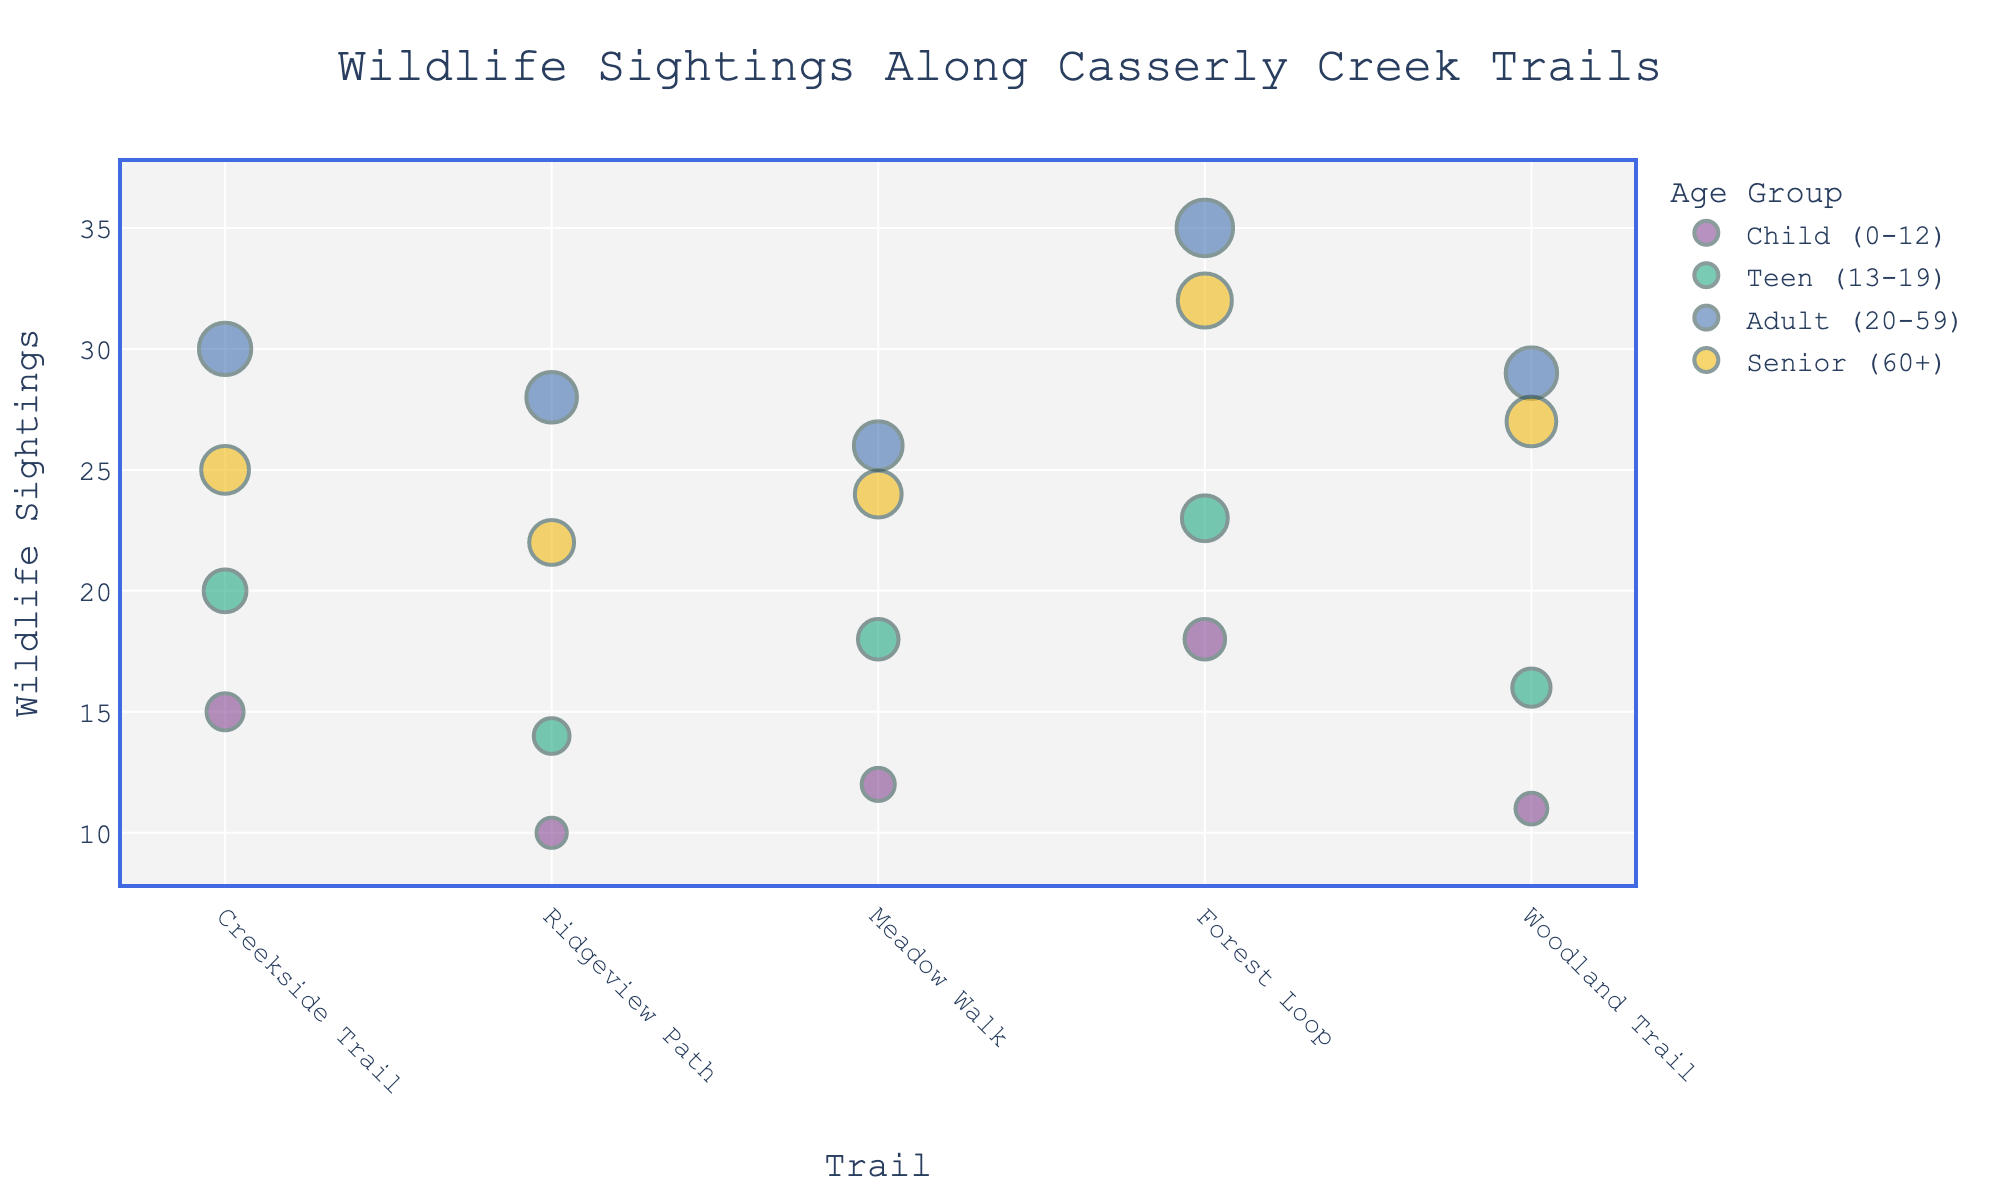What is the title of the plot? The title is typically located at the top of the plot and provides a brief description. The text should be read from the plot.
Answer: Wildlife Sightings Along Casserly Creek Trails Which trail and age group combination has the highest number of wildlife sightings? Look for the data point with the largest marker, which indicates the highest number of sightings. The trail and age group can be identified from the hover information.
Answer: Forest Loop, Adult (20-59) How many wildlife sightings were recorded for Teens (13-19) on Woodland Trail? Locate the marker on Woodland Trail corresponding to the Teen (13-19) age group, using the color to identify the correct data point.
Answer: 16 What is the total number of wildlife sightings on Creekside Trail? Sum the number of sightings for all age groups on Creekside Trail: 15 (Child) + 20 (Teen) + 30 (Adult) + 25 (Senior).
Answer: 90 Which age group has the most wildlife sightings in total across all trails? Sum the sightings for each age group across all trails, then compare the sums. Detailed steps:
- Child: 15 + 10 + 12 + 18 + 11 = 66
- Teen: 20 + 14 + 18 + 23 + 16 = 91
- Adult: 30 + 28 + 26 + 35 + 29 = 148
- Senior: 25 + 22 + 24 + 32 + 27 = 130
The Adult (20-59) age group has the highest sum.
Answer: Adult (20-59) Compare the number of wildlife sightings between Ridgeview Path and Meadow Walk. Which has more sightings? Sum the sightings for all age groups on Ridgeview Path and Meadow Walk respectively:
- Ridgeview Path: 10 (Child) + 14 (Teen) + 28 (Adult) + 22 (Senior) = 74
- Meadow Walk: 12 (Child) + 18 (Teen) + 26 (Adult) + 24 (Senior) = 80
Compare the totals.
Answer: Meadow Walk What is the average number of wildlife sightings for Seniors (60+) across all trails? Calculate the average by summing the sightings for Seniors across all trails and dividing by the number of trails:
(25 + 22 + 24 + 32 + 27) / 5 = 130 / 5.
Answer: 26 Which trail has the most uniform distribution of wildlife sightings across all age groups? Look for the trail where the number of sightings is most similar across all four age groups, minimizing the range between the highest and lowest sightings.
Answer: Meadow Walk What is the difference in wildlife sightings between the most frequently sighted age group on Forest Loop and the least sighted age group on the same trail? Identify the number of sightings for each age group on Forest Loop:
- Child (0-12): 18
- Teen (13-19): 23
- Adult (20-59): 35
- Senior (60+): 32
Calculate the difference between the highest (Adult: 35) and lowest (Child: 18): 35 - 18.
Answer: 17 Do Teens (13-19) or Children (0-12) have more total wildlife sightings across all trails? Sum the sightings for Teens and Children across all trails and compare:
- Child (0-12): 15 + 10 + 12 + 18 + 11 = 66
- Teen (13-19): 20 + 14 + 18 + 23 + 16 = 91
Compare the totals.
Answer: Teens (13-19) 